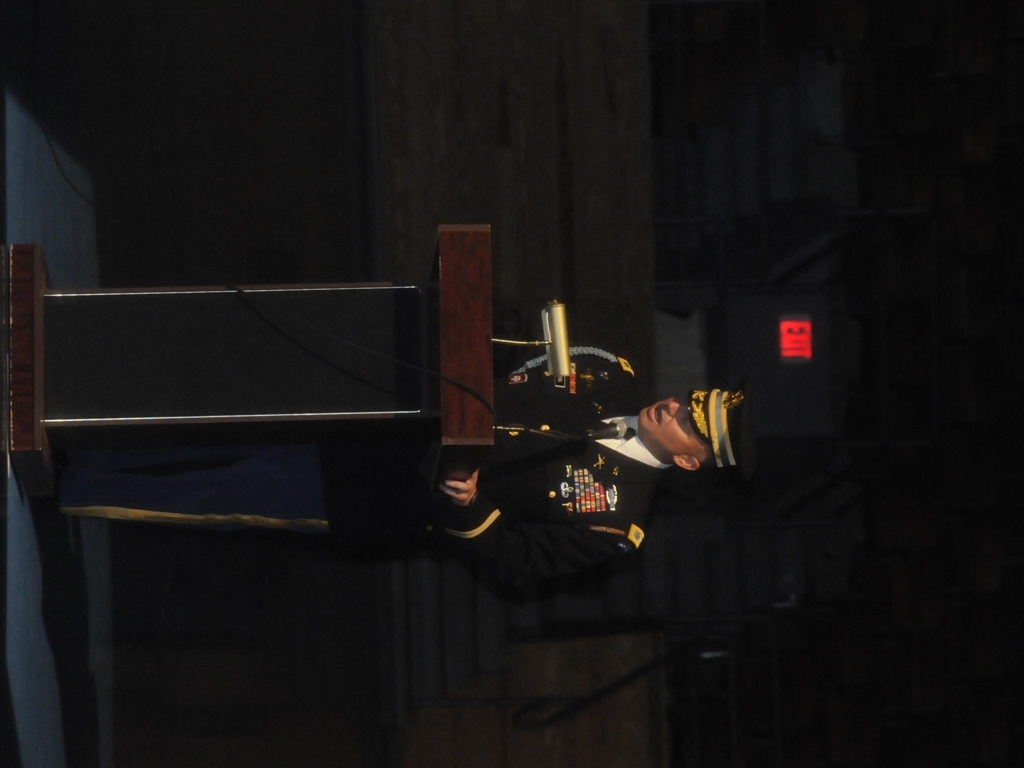What emotions does the speaker seem to be portraying? The speaker's posture and facial expression convey a sense of gravity and formality, perhaps delivering a speech with significant importance or commemoration. 